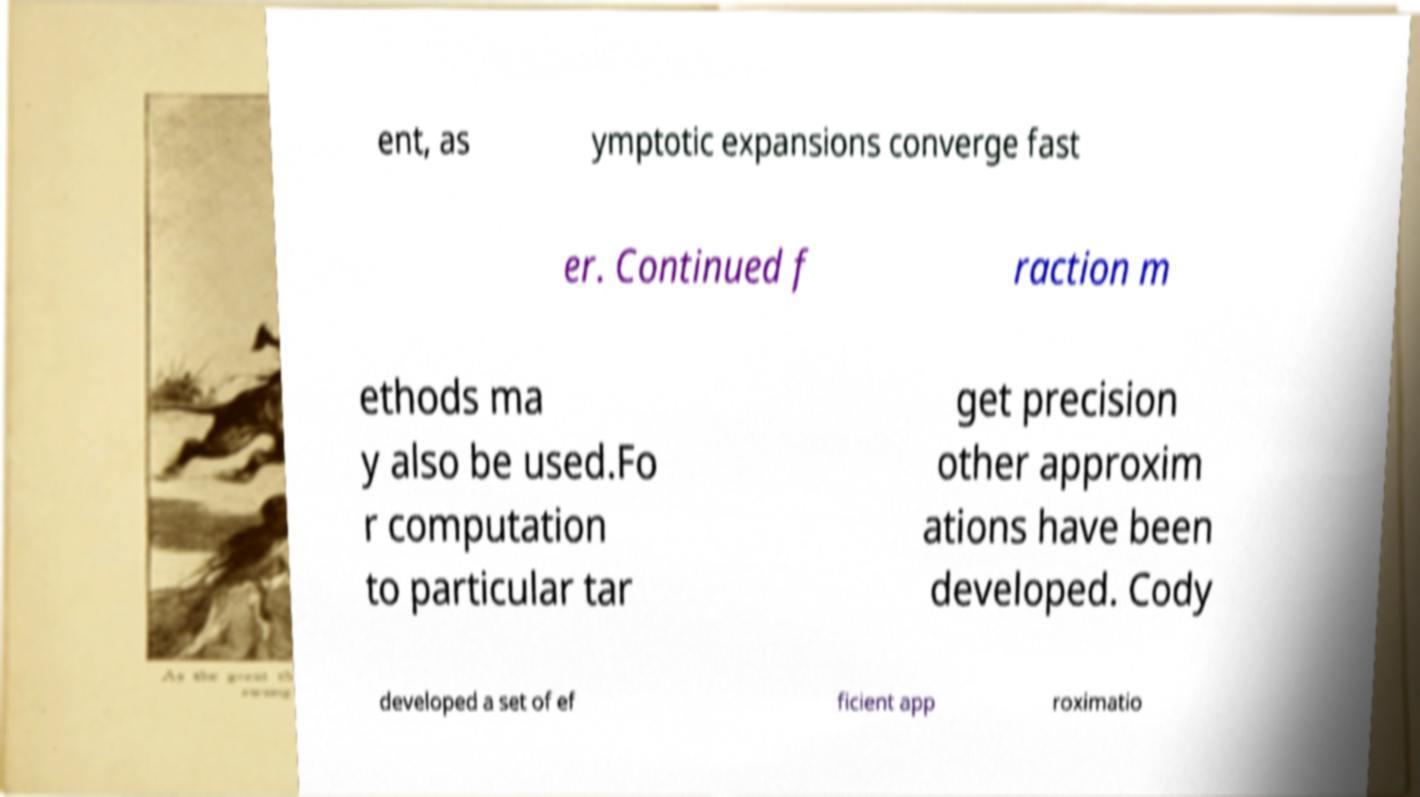Can you read and provide the text displayed in the image?This photo seems to have some interesting text. Can you extract and type it out for me? ent, as ymptotic expansions converge fast er. Continued f raction m ethods ma y also be used.Fo r computation to particular tar get precision other approxim ations have been developed. Cody developed a set of ef ficient app roximatio 